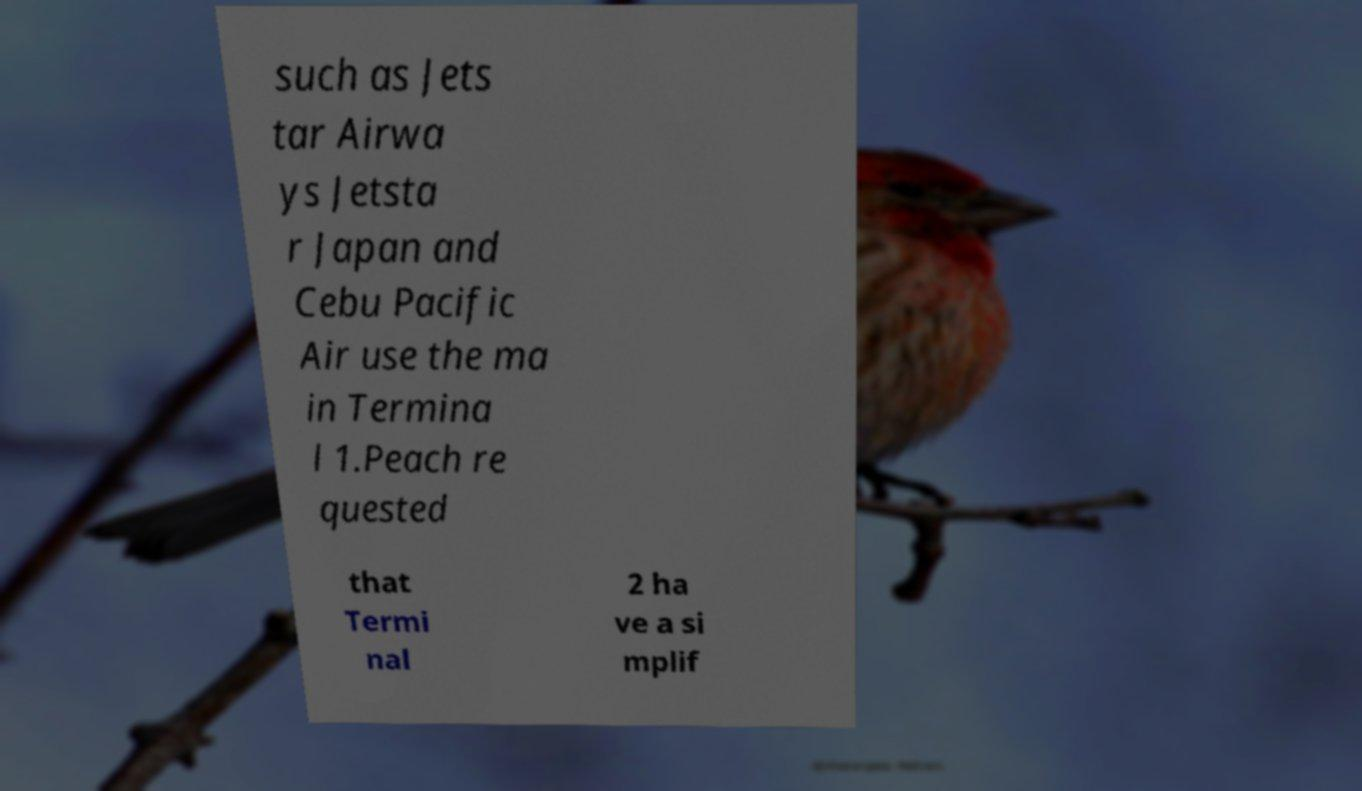Could you extract and type out the text from this image? such as Jets tar Airwa ys Jetsta r Japan and Cebu Pacific Air use the ma in Termina l 1.Peach re quested that Termi nal 2 ha ve a si mplif 